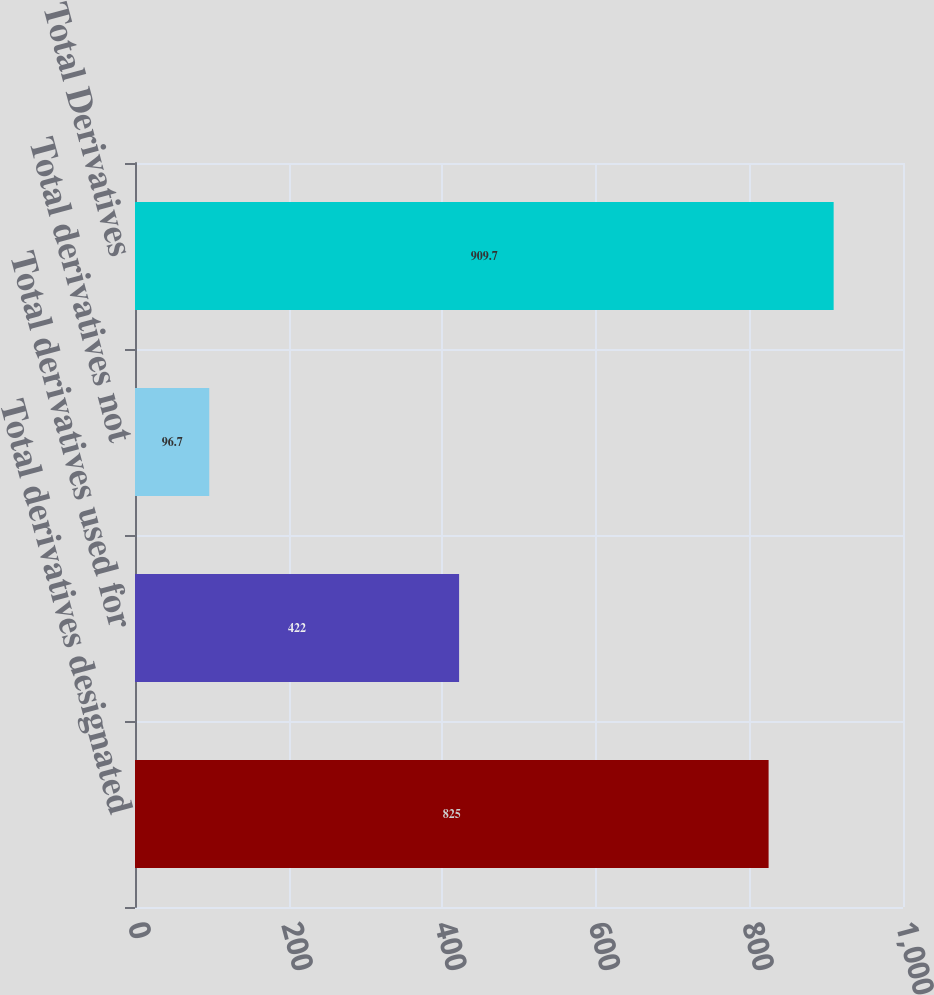Convert chart to OTSL. <chart><loc_0><loc_0><loc_500><loc_500><bar_chart><fcel>Total derivatives designated<fcel>Total derivatives used for<fcel>Total derivatives not<fcel>Total Derivatives<nl><fcel>825<fcel>422<fcel>96.7<fcel>909.7<nl></chart> 